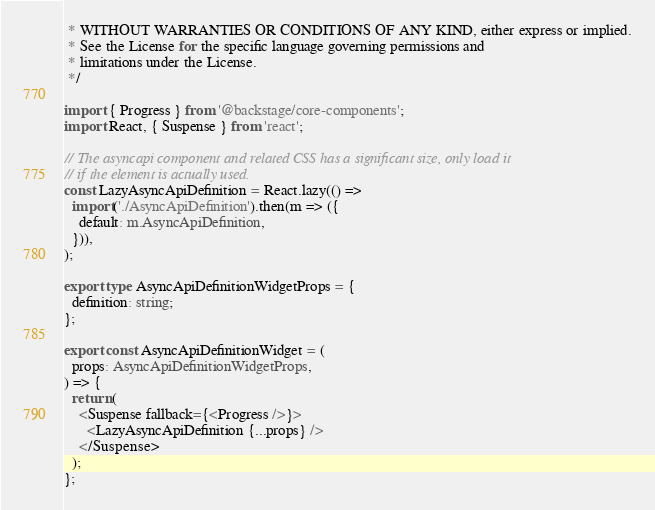Convert code to text. <code><loc_0><loc_0><loc_500><loc_500><_TypeScript_> * WITHOUT WARRANTIES OR CONDITIONS OF ANY KIND, either express or implied.
 * See the License for the specific language governing permissions and
 * limitations under the License.
 */

import { Progress } from '@backstage/core-components';
import React, { Suspense } from 'react';

// The asyncapi component and related CSS has a significant size, only load it
// if the element is actually used.
const LazyAsyncApiDefinition = React.lazy(() =>
  import('./AsyncApiDefinition').then(m => ({
    default: m.AsyncApiDefinition,
  })),
);

export type AsyncApiDefinitionWidgetProps = {
  definition: string;
};

export const AsyncApiDefinitionWidget = (
  props: AsyncApiDefinitionWidgetProps,
) => {
  return (
    <Suspense fallback={<Progress />}>
      <LazyAsyncApiDefinition {...props} />
    </Suspense>
  );
};
</code> 